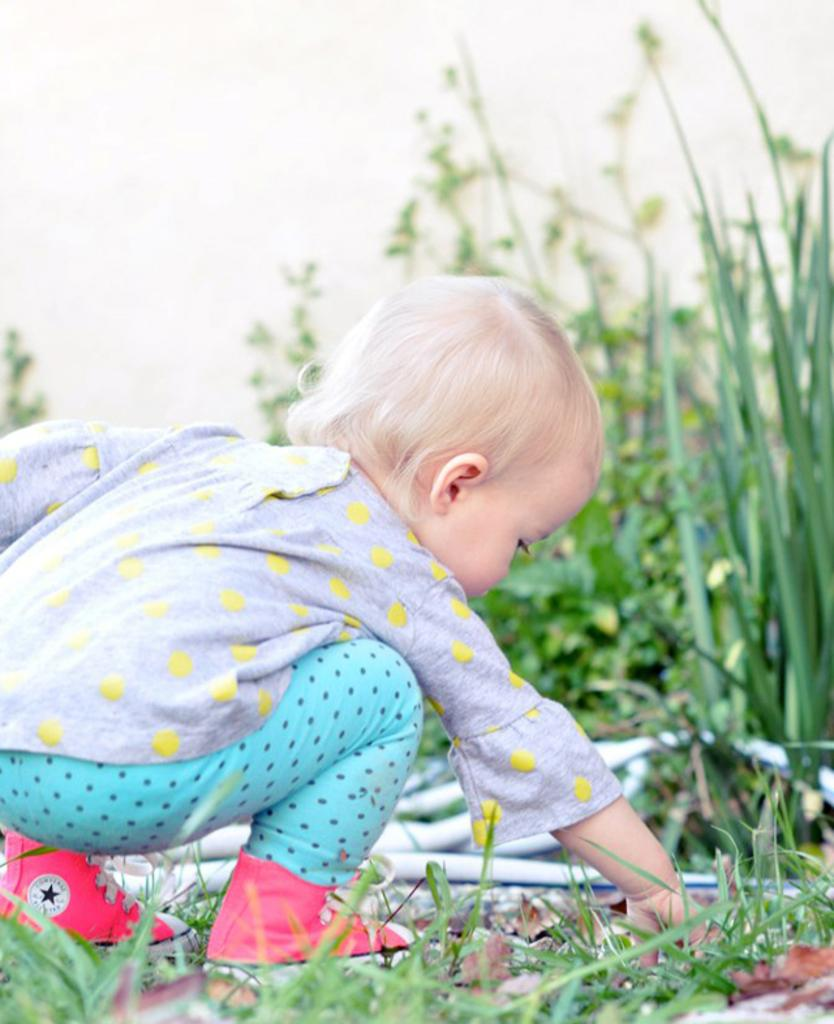What is the child doing in the image? The child is on the ground in the image. What type of vegetation can be seen in the image? Dried leaves and grass are visible in the image. What else can be seen in the image besides the child and vegetation? There are objects and plants in the background of the image. What is visible in the background of the image? The sky is visible in the background of the image. Can you hear the child laughing in the image? The image is silent, so it is not possible to hear the child laughing. 